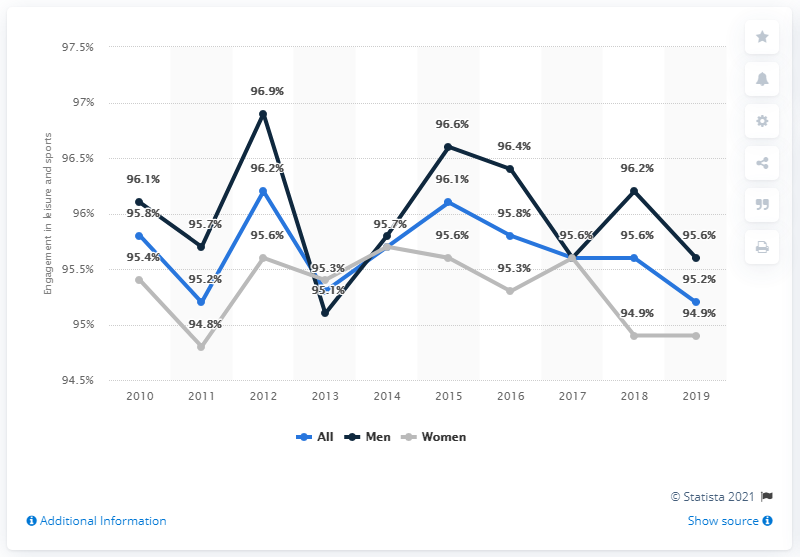List a handful of essential elements in this visual. In 2012, there was the highest difference between male and female engagement in sports and leisure activities. In 2012, the percentage of men engaging in sports and leisure activities was the highest on record. 